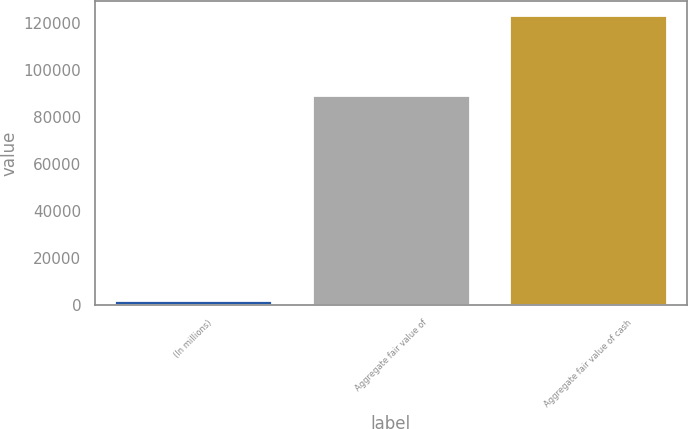Convert chart. <chart><loc_0><loc_0><loc_500><loc_500><bar_chart><fcel>(In millions)<fcel>Aggregate fair value of<fcel>Aggregate fair value of cash<nl><fcel>2010<fcel>89069<fcel>123209<nl></chart> 